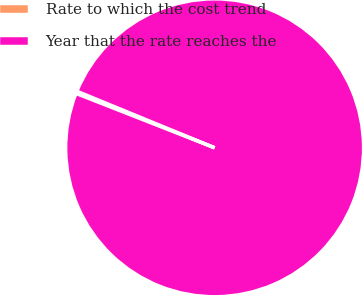Convert chart. <chart><loc_0><loc_0><loc_500><loc_500><pie_chart><fcel>Rate to which the cost trend<fcel>Year that the rate reaches the<nl><fcel>0.25%<fcel>99.75%<nl></chart> 